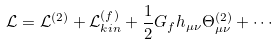Convert formula to latex. <formula><loc_0><loc_0><loc_500><loc_500>\mathcal { L } = \mathcal { L } ^ { ( 2 ) } + \mathcal { L } _ { k i n } ^ { ( f ) } + \frac { 1 } { 2 } G _ { f } h _ { \mu \nu } \Theta ^ { ( 2 ) } _ { \mu \nu } + \cdots</formula> 